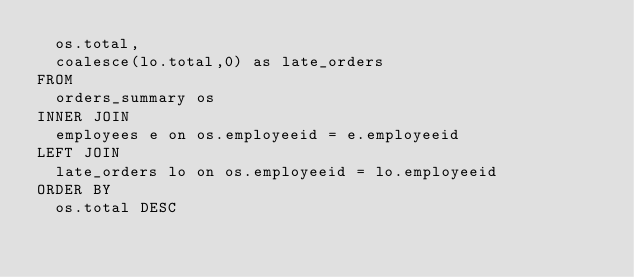Convert code to text. <code><loc_0><loc_0><loc_500><loc_500><_SQL_>  os.total,
  coalesce(lo.total,0) as late_orders
FROM
  orders_summary os
INNER JOIN
  employees e on os.employeeid = e.employeeid
LEFT JOIN
  late_orders lo on os.employeeid = lo.employeeid
ORDER BY
  os.total DESC</code> 